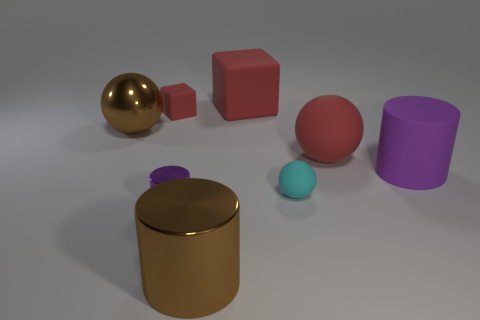Add 2 small brown spheres. How many objects exist? 10 Subtract all spheres. How many objects are left? 5 Subtract all tiny metallic objects. Subtract all red objects. How many objects are left? 4 Add 5 shiny balls. How many shiny balls are left? 6 Add 6 large purple metallic things. How many large purple metallic things exist? 6 Subtract 2 red blocks. How many objects are left? 6 